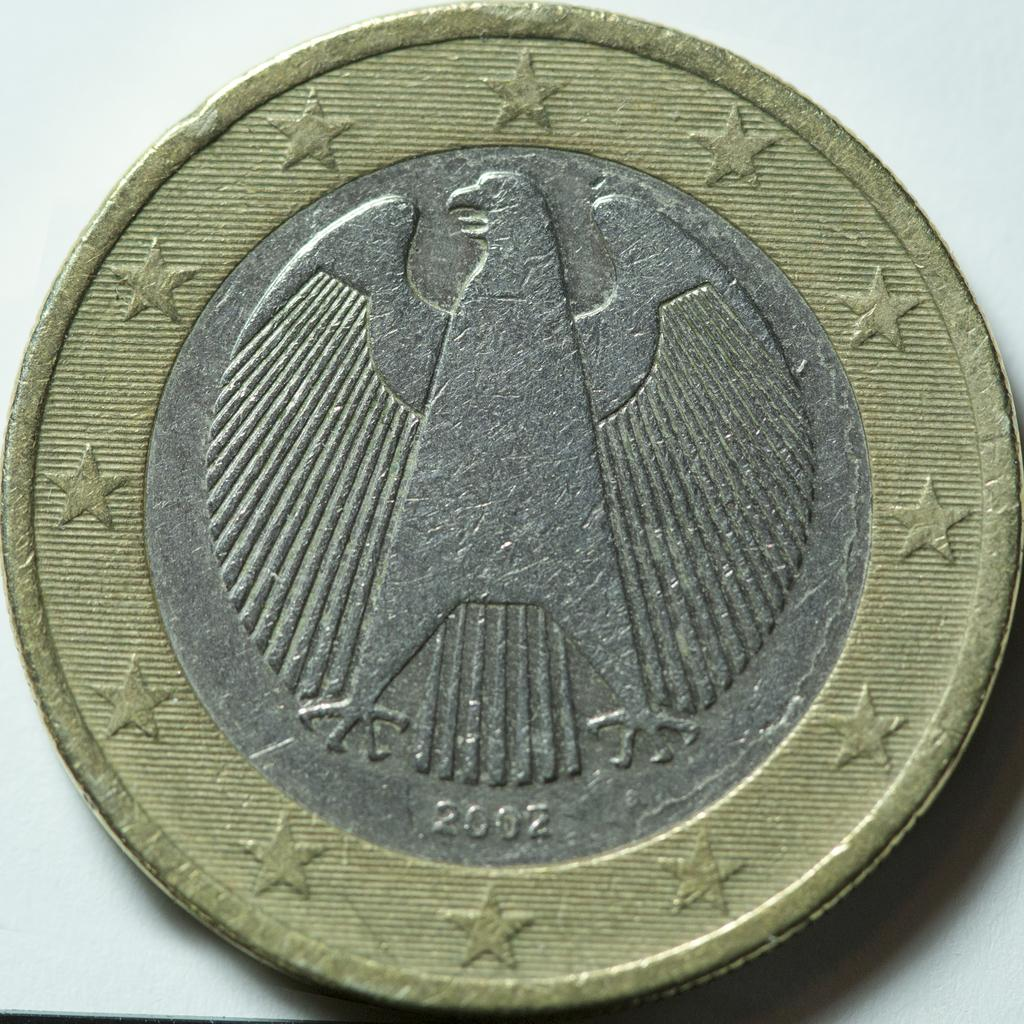Provide a one-sentence caption for the provided image. A coin with an eagle on it was minted in the year 2002. 